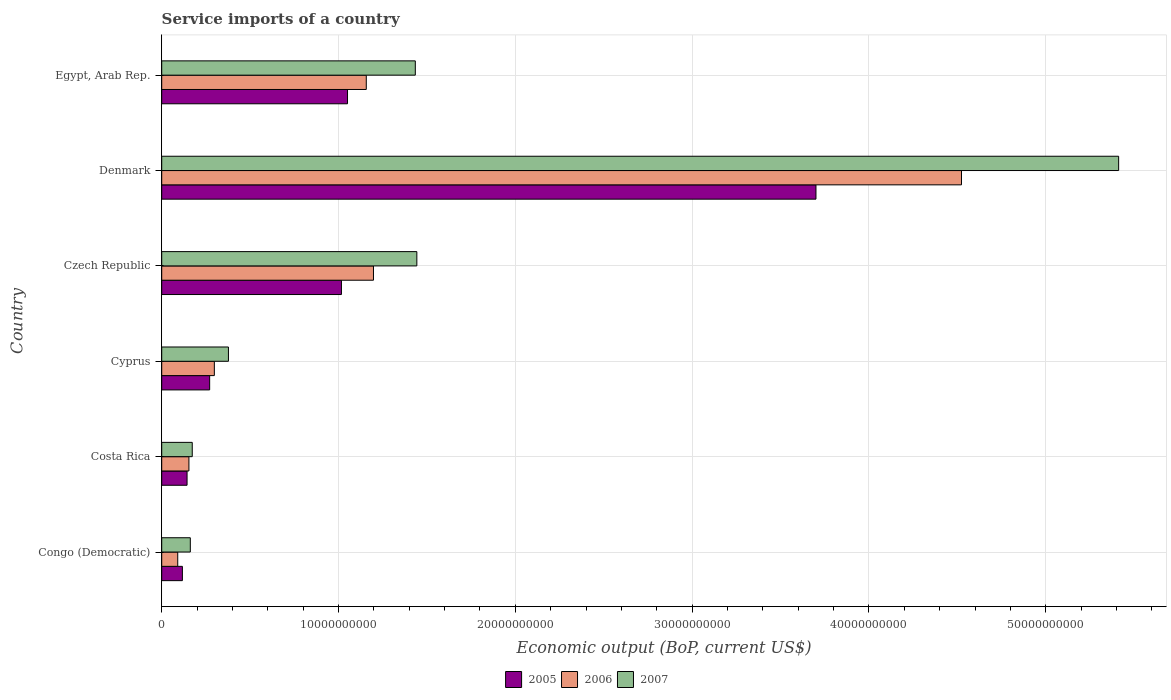How many different coloured bars are there?
Make the answer very short. 3. How many bars are there on the 5th tick from the top?
Your answer should be compact. 3. What is the label of the 3rd group of bars from the top?
Your answer should be compact. Czech Republic. In how many cases, is the number of bars for a given country not equal to the number of legend labels?
Your response must be concise. 0. What is the service imports in 2005 in Egypt, Arab Rep.?
Offer a very short reply. 1.05e+1. Across all countries, what is the maximum service imports in 2007?
Offer a terse response. 5.41e+1. Across all countries, what is the minimum service imports in 2007?
Make the answer very short. 1.62e+09. In which country was the service imports in 2007 maximum?
Make the answer very short. Denmark. In which country was the service imports in 2007 minimum?
Offer a very short reply. Congo (Democratic). What is the total service imports in 2006 in the graph?
Provide a succinct answer. 7.42e+1. What is the difference between the service imports in 2006 in Cyprus and that in Egypt, Arab Rep.?
Provide a short and direct response. -8.59e+09. What is the difference between the service imports in 2005 in Congo (Democratic) and the service imports in 2007 in Egypt, Arab Rep.?
Provide a short and direct response. -1.32e+1. What is the average service imports in 2006 per country?
Provide a succinct answer. 1.24e+1. What is the difference between the service imports in 2005 and service imports in 2007 in Denmark?
Ensure brevity in your answer.  -1.71e+1. What is the ratio of the service imports in 2006 in Congo (Democratic) to that in Cyprus?
Ensure brevity in your answer.  0.3. What is the difference between the highest and the second highest service imports in 2005?
Provide a short and direct response. 2.65e+1. What is the difference between the highest and the lowest service imports in 2007?
Offer a terse response. 5.25e+1. What does the 1st bar from the top in Czech Republic represents?
Offer a very short reply. 2007. Are the values on the major ticks of X-axis written in scientific E-notation?
Keep it short and to the point. No. Does the graph contain any zero values?
Make the answer very short. No. How many legend labels are there?
Keep it short and to the point. 3. What is the title of the graph?
Make the answer very short. Service imports of a country. What is the label or title of the X-axis?
Provide a short and direct response. Economic output (BoP, current US$). What is the Economic output (BoP, current US$) in 2005 in Congo (Democratic)?
Offer a terse response. 1.17e+09. What is the Economic output (BoP, current US$) of 2006 in Congo (Democratic)?
Make the answer very short. 9.06e+08. What is the Economic output (BoP, current US$) in 2007 in Congo (Democratic)?
Your response must be concise. 1.62e+09. What is the Economic output (BoP, current US$) of 2005 in Costa Rica?
Your answer should be very brief. 1.43e+09. What is the Economic output (BoP, current US$) of 2006 in Costa Rica?
Your answer should be compact. 1.54e+09. What is the Economic output (BoP, current US$) in 2007 in Costa Rica?
Make the answer very short. 1.73e+09. What is the Economic output (BoP, current US$) of 2005 in Cyprus?
Provide a succinct answer. 2.71e+09. What is the Economic output (BoP, current US$) of 2006 in Cyprus?
Provide a succinct answer. 2.98e+09. What is the Economic output (BoP, current US$) of 2007 in Cyprus?
Give a very brief answer. 3.77e+09. What is the Economic output (BoP, current US$) of 2005 in Czech Republic?
Your answer should be very brief. 1.02e+1. What is the Economic output (BoP, current US$) of 2006 in Czech Republic?
Make the answer very short. 1.20e+1. What is the Economic output (BoP, current US$) of 2007 in Czech Republic?
Offer a very short reply. 1.44e+1. What is the Economic output (BoP, current US$) in 2005 in Denmark?
Provide a short and direct response. 3.70e+1. What is the Economic output (BoP, current US$) in 2006 in Denmark?
Offer a very short reply. 4.52e+1. What is the Economic output (BoP, current US$) in 2007 in Denmark?
Provide a succinct answer. 5.41e+1. What is the Economic output (BoP, current US$) in 2005 in Egypt, Arab Rep.?
Keep it short and to the point. 1.05e+1. What is the Economic output (BoP, current US$) of 2006 in Egypt, Arab Rep.?
Provide a succinct answer. 1.16e+1. What is the Economic output (BoP, current US$) of 2007 in Egypt, Arab Rep.?
Provide a short and direct response. 1.43e+1. Across all countries, what is the maximum Economic output (BoP, current US$) of 2005?
Provide a short and direct response. 3.70e+1. Across all countries, what is the maximum Economic output (BoP, current US$) in 2006?
Offer a very short reply. 4.52e+1. Across all countries, what is the maximum Economic output (BoP, current US$) in 2007?
Keep it short and to the point. 5.41e+1. Across all countries, what is the minimum Economic output (BoP, current US$) in 2005?
Offer a very short reply. 1.17e+09. Across all countries, what is the minimum Economic output (BoP, current US$) of 2006?
Your answer should be compact. 9.06e+08. Across all countries, what is the minimum Economic output (BoP, current US$) of 2007?
Your response must be concise. 1.62e+09. What is the total Economic output (BoP, current US$) in 2005 in the graph?
Keep it short and to the point. 6.30e+1. What is the total Economic output (BoP, current US$) in 2006 in the graph?
Give a very brief answer. 7.42e+1. What is the total Economic output (BoP, current US$) in 2007 in the graph?
Make the answer very short. 9.00e+1. What is the difference between the Economic output (BoP, current US$) of 2005 in Congo (Democratic) and that in Costa Rica?
Keep it short and to the point. -2.65e+08. What is the difference between the Economic output (BoP, current US$) of 2006 in Congo (Democratic) and that in Costa Rica?
Provide a short and direct response. -6.33e+08. What is the difference between the Economic output (BoP, current US$) in 2007 in Congo (Democratic) and that in Costa Rica?
Provide a short and direct response. -1.09e+08. What is the difference between the Economic output (BoP, current US$) in 2005 in Congo (Democratic) and that in Cyprus?
Make the answer very short. -1.54e+09. What is the difference between the Economic output (BoP, current US$) in 2006 in Congo (Democratic) and that in Cyprus?
Ensure brevity in your answer.  -2.07e+09. What is the difference between the Economic output (BoP, current US$) of 2007 in Congo (Democratic) and that in Cyprus?
Your response must be concise. -2.16e+09. What is the difference between the Economic output (BoP, current US$) of 2005 in Congo (Democratic) and that in Czech Republic?
Offer a terse response. -9.00e+09. What is the difference between the Economic output (BoP, current US$) in 2006 in Congo (Democratic) and that in Czech Republic?
Ensure brevity in your answer.  -1.11e+1. What is the difference between the Economic output (BoP, current US$) in 2007 in Congo (Democratic) and that in Czech Republic?
Your answer should be compact. -1.28e+1. What is the difference between the Economic output (BoP, current US$) in 2005 in Congo (Democratic) and that in Denmark?
Your response must be concise. -3.58e+1. What is the difference between the Economic output (BoP, current US$) of 2006 in Congo (Democratic) and that in Denmark?
Offer a very short reply. -4.43e+1. What is the difference between the Economic output (BoP, current US$) of 2007 in Congo (Democratic) and that in Denmark?
Ensure brevity in your answer.  -5.25e+1. What is the difference between the Economic output (BoP, current US$) of 2005 in Congo (Democratic) and that in Egypt, Arab Rep.?
Offer a terse response. -9.34e+09. What is the difference between the Economic output (BoP, current US$) of 2006 in Congo (Democratic) and that in Egypt, Arab Rep.?
Make the answer very short. -1.07e+1. What is the difference between the Economic output (BoP, current US$) of 2007 in Congo (Democratic) and that in Egypt, Arab Rep.?
Your answer should be very brief. -1.27e+1. What is the difference between the Economic output (BoP, current US$) in 2005 in Costa Rica and that in Cyprus?
Keep it short and to the point. -1.28e+09. What is the difference between the Economic output (BoP, current US$) in 2006 in Costa Rica and that in Cyprus?
Offer a very short reply. -1.44e+09. What is the difference between the Economic output (BoP, current US$) of 2007 in Costa Rica and that in Cyprus?
Keep it short and to the point. -2.05e+09. What is the difference between the Economic output (BoP, current US$) of 2005 in Costa Rica and that in Czech Republic?
Make the answer very short. -8.73e+09. What is the difference between the Economic output (BoP, current US$) in 2006 in Costa Rica and that in Czech Republic?
Your answer should be compact. -1.04e+1. What is the difference between the Economic output (BoP, current US$) in 2007 in Costa Rica and that in Czech Republic?
Your response must be concise. -1.27e+1. What is the difference between the Economic output (BoP, current US$) of 2005 in Costa Rica and that in Denmark?
Your response must be concise. -3.56e+1. What is the difference between the Economic output (BoP, current US$) of 2006 in Costa Rica and that in Denmark?
Give a very brief answer. -4.37e+1. What is the difference between the Economic output (BoP, current US$) of 2007 in Costa Rica and that in Denmark?
Make the answer very short. -5.24e+1. What is the difference between the Economic output (BoP, current US$) of 2005 in Costa Rica and that in Egypt, Arab Rep.?
Ensure brevity in your answer.  -9.07e+09. What is the difference between the Economic output (BoP, current US$) in 2006 in Costa Rica and that in Egypt, Arab Rep.?
Provide a short and direct response. -1.00e+1. What is the difference between the Economic output (BoP, current US$) of 2007 in Costa Rica and that in Egypt, Arab Rep.?
Make the answer very short. -1.26e+1. What is the difference between the Economic output (BoP, current US$) in 2005 in Cyprus and that in Czech Republic?
Provide a succinct answer. -7.45e+09. What is the difference between the Economic output (BoP, current US$) in 2006 in Cyprus and that in Czech Republic?
Provide a short and direct response. -9.00e+09. What is the difference between the Economic output (BoP, current US$) in 2007 in Cyprus and that in Czech Republic?
Your answer should be very brief. -1.07e+1. What is the difference between the Economic output (BoP, current US$) in 2005 in Cyprus and that in Denmark?
Give a very brief answer. -3.43e+1. What is the difference between the Economic output (BoP, current US$) in 2006 in Cyprus and that in Denmark?
Provide a succinct answer. -4.23e+1. What is the difference between the Economic output (BoP, current US$) of 2007 in Cyprus and that in Denmark?
Ensure brevity in your answer.  -5.03e+1. What is the difference between the Economic output (BoP, current US$) of 2005 in Cyprus and that in Egypt, Arab Rep.?
Make the answer very short. -7.80e+09. What is the difference between the Economic output (BoP, current US$) in 2006 in Cyprus and that in Egypt, Arab Rep.?
Make the answer very short. -8.59e+09. What is the difference between the Economic output (BoP, current US$) of 2007 in Cyprus and that in Egypt, Arab Rep.?
Your response must be concise. -1.06e+1. What is the difference between the Economic output (BoP, current US$) of 2005 in Czech Republic and that in Denmark?
Offer a terse response. -2.68e+1. What is the difference between the Economic output (BoP, current US$) in 2006 in Czech Republic and that in Denmark?
Your answer should be very brief. -3.33e+1. What is the difference between the Economic output (BoP, current US$) in 2007 in Czech Republic and that in Denmark?
Provide a short and direct response. -3.97e+1. What is the difference between the Economic output (BoP, current US$) in 2005 in Czech Republic and that in Egypt, Arab Rep.?
Your answer should be compact. -3.44e+08. What is the difference between the Economic output (BoP, current US$) in 2006 in Czech Republic and that in Egypt, Arab Rep.?
Offer a terse response. 4.07e+08. What is the difference between the Economic output (BoP, current US$) in 2007 in Czech Republic and that in Egypt, Arab Rep.?
Offer a very short reply. 8.66e+07. What is the difference between the Economic output (BoP, current US$) in 2005 in Denmark and that in Egypt, Arab Rep.?
Offer a very short reply. 2.65e+1. What is the difference between the Economic output (BoP, current US$) in 2006 in Denmark and that in Egypt, Arab Rep.?
Give a very brief answer. 3.37e+1. What is the difference between the Economic output (BoP, current US$) in 2007 in Denmark and that in Egypt, Arab Rep.?
Make the answer very short. 3.98e+1. What is the difference between the Economic output (BoP, current US$) in 2005 in Congo (Democratic) and the Economic output (BoP, current US$) in 2006 in Costa Rica?
Keep it short and to the point. -3.70e+08. What is the difference between the Economic output (BoP, current US$) in 2005 in Congo (Democratic) and the Economic output (BoP, current US$) in 2007 in Costa Rica?
Give a very brief answer. -5.58e+08. What is the difference between the Economic output (BoP, current US$) in 2006 in Congo (Democratic) and the Economic output (BoP, current US$) in 2007 in Costa Rica?
Keep it short and to the point. -8.21e+08. What is the difference between the Economic output (BoP, current US$) in 2005 in Congo (Democratic) and the Economic output (BoP, current US$) in 2006 in Cyprus?
Provide a succinct answer. -1.81e+09. What is the difference between the Economic output (BoP, current US$) of 2005 in Congo (Democratic) and the Economic output (BoP, current US$) of 2007 in Cyprus?
Keep it short and to the point. -2.60e+09. What is the difference between the Economic output (BoP, current US$) of 2006 in Congo (Democratic) and the Economic output (BoP, current US$) of 2007 in Cyprus?
Your answer should be very brief. -2.87e+09. What is the difference between the Economic output (BoP, current US$) of 2005 in Congo (Democratic) and the Economic output (BoP, current US$) of 2006 in Czech Republic?
Keep it short and to the point. -1.08e+1. What is the difference between the Economic output (BoP, current US$) of 2005 in Congo (Democratic) and the Economic output (BoP, current US$) of 2007 in Czech Republic?
Provide a short and direct response. -1.33e+1. What is the difference between the Economic output (BoP, current US$) of 2006 in Congo (Democratic) and the Economic output (BoP, current US$) of 2007 in Czech Republic?
Provide a short and direct response. -1.35e+1. What is the difference between the Economic output (BoP, current US$) of 2005 in Congo (Democratic) and the Economic output (BoP, current US$) of 2006 in Denmark?
Your response must be concise. -4.41e+1. What is the difference between the Economic output (BoP, current US$) in 2005 in Congo (Democratic) and the Economic output (BoP, current US$) in 2007 in Denmark?
Ensure brevity in your answer.  -5.30e+1. What is the difference between the Economic output (BoP, current US$) of 2006 in Congo (Democratic) and the Economic output (BoP, current US$) of 2007 in Denmark?
Your answer should be compact. -5.32e+1. What is the difference between the Economic output (BoP, current US$) in 2005 in Congo (Democratic) and the Economic output (BoP, current US$) in 2006 in Egypt, Arab Rep.?
Provide a short and direct response. -1.04e+1. What is the difference between the Economic output (BoP, current US$) in 2005 in Congo (Democratic) and the Economic output (BoP, current US$) in 2007 in Egypt, Arab Rep.?
Give a very brief answer. -1.32e+1. What is the difference between the Economic output (BoP, current US$) of 2006 in Congo (Democratic) and the Economic output (BoP, current US$) of 2007 in Egypt, Arab Rep.?
Offer a terse response. -1.34e+1. What is the difference between the Economic output (BoP, current US$) of 2005 in Costa Rica and the Economic output (BoP, current US$) of 2006 in Cyprus?
Provide a succinct answer. -1.54e+09. What is the difference between the Economic output (BoP, current US$) in 2005 in Costa Rica and the Economic output (BoP, current US$) in 2007 in Cyprus?
Give a very brief answer. -2.34e+09. What is the difference between the Economic output (BoP, current US$) in 2006 in Costa Rica and the Economic output (BoP, current US$) in 2007 in Cyprus?
Offer a very short reply. -2.23e+09. What is the difference between the Economic output (BoP, current US$) in 2005 in Costa Rica and the Economic output (BoP, current US$) in 2006 in Czech Republic?
Your response must be concise. -1.05e+1. What is the difference between the Economic output (BoP, current US$) of 2005 in Costa Rica and the Economic output (BoP, current US$) of 2007 in Czech Republic?
Your answer should be compact. -1.30e+1. What is the difference between the Economic output (BoP, current US$) of 2006 in Costa Rica and the Economic output (BoP, current US$) of 2007 in Czech Republic?
Provide a short and direct response. -1.29e+1. What is the difference between the Economic output (BoP, current US$) in 2005 in Costa Rica and the Economic output (BoP, current US$) in 2006 in Denmark?
Offer a very short reply. -4.38e+1. What is the difference between the Economic output (BoP, current US$) in 2005 in Costa Rica and the Economic output (BoP, current US$) in 2007 in Denmark?
Provide a short and direct response. -5.27e+1. What is the difference between the Economic output (BoP, current US$) of 2006 in Costa Rica and the Economic output (BoP, current US$) of 2007 in Denmark?
Provide a short and direct response. -5.26e+1. What is the difference between the Economic output (BoP, current US$) in 2005 in Costa Rica and the Economic output (BoP, current US$) in 2006 in Egypt, Arab Rep.?
Your response must be concise. -1.01e+1. What is the difference between the Economic output (BoP, current US$) of 2005 in Costa Rica and the Economic output (BoP, current US$) of 2007 in Egypt, Arab Rep.?
Provide a short and direct response. -1.29e+1. What is the difference between the Economic output (BoP, current US$) in 2006 in Costa Rica and the Economic output (BoP, current US$) in 2007 in Egypt, Arab Rep.?
Your response must be concise. -1.28e+1. What is the difference between the Economic output (BoP, current US$) of 2005 in Cyprus and the Economic output (BoP, current US$) of 2006 in Czech Republic?
Make the answer very short. -9.26e+09. What is the difference between the Economic output (BoP, current US$) in 2005 in Cyprus and the Economic output (BoP, current US$) in 2007 in Czech Republic?
Your answer should be very brief. -1.17e+1. What is the difference between the Economic output (BoP, current US$) of 2006 in Cyprus and the Economic output (BoP, current US$) of 2007 in Czech Republic?
Your answer should be compact. -1.15e+1. What is the difference between the Economic output (BoP, current US$) in 2005 in Cyprus and the Economic output (BoP, current US$) in 2006 in Denmark?
Your answer should be compact. -4.25e+1. What is the difference between the Economic output (BoP, current US$) of 2005 in Cyprus and the Economic output (BoP, current US$) of 2007 in Denmark?
Keep it short and to the point. -5.14e+1. What is the difference between the Economic output (BoP, current US$) of 2006 in Cyprus and the Economic output (BoP, current US$) of 2007 in Denmark?
Make the answer very short. -5.11e+1. What is the difference between the Economic output (BoP, current US$) in 2005 in Cyprus and the Economic output (BoP, current US$) in 2006 in Egypt, Arab Rep.?
Give a very brief answer. -8.86e+09. What is the difference between the Economic output (BoP, current US$) in 2005 in Cyprus and the Economic output (BoP, current US$) in 2007 in Egypt, Arab Rep.?
Offer a terse response. -1.16e+1. What is the difference between the Economic output (BoP, current US$) in 2006 in Cyprus and the Economic output (BoP, current US$) in 2007 in Egypt, Arab Rep.?
Your answer should be compact. -1.14e+1. What is the difference between the Economic output (BoP, current US$) in 2005 in Czech Republic and the Economic output (BoP, current US$) in 2006 in Denmark?
Provide a succinct answer. -3.51e+1. What is the difference between the Economic output (BoP, current US$) of 2005 in Czech Republic and the Economic output (BoP, current US$) of 2007 in Denmark?
Provide a short and direct response. -4.40e+1. What is the difference between the Economic output (BoP, current US$) of 2006 in Czech Republic and the Economic output (BoP, current US$) of 2007 in Denmark?
Your answer should be compact. -4.21e+1. What is the difference between the Economic output (BoP, current US$) in 2005 in Czech Republic and the Economic output (BoP, current US$) in 2006 in Egypt, Arab Rep.?
Offer a very short reply. -1.40e+09. What is the difference between the Economic output (BoP, current US$) of 2005 in Czech Republic and the Economic output (BoP, current US$) of 2007 in Egypt, Arab Rep.?
Offer a very short reply. -4.18e+09. What is the difference between the Economic output (BoP, current US$) of 2006 in Czech Republic and the Economic output (BoP, current US$) of 2007 in Egypt, Arab Rep.?
Provide a succinct answer. -2.37e+09. What is the difference between the Economic output (BoP, current US$) in 2005 in Denmark and the Economic output (BoP, current US$) in 2006 in Egypt, Arab Rep.?
Provide a succinct answer. 2.54e+1. What is the difference between the Economic output (BoP, current US$) in 2005 in Denmark and the Economic output (BoP, current US$) in 2007 in Egypt, Arab Rep.?
Your answer should be very brief. 2.27e+1. What is the difference between the Economic output (BoP, current US$) of 2006 in Denmark and the Economic output (BoP, current US$) of 2007 in Egypt, Arab Rep.?
Offer a very short reply. 3.09e+1. What is the average Economic output (BoP, current US$) in 2005 per country?
Your answer should be compact. 1.05e+1. What is the average Economic output (BoP, current US$) in 2006 per country?
Provide a succinct answer. 1.24e+1. What is the average Economic output (BoP, current US$) of 2007 per country?
Your response must be concise. 1.50e+1. What is the difference between the Economic output (BoP, current US$) in 2005 and Economic output (BoP, current US$) in 2006 in Congo (Democratic)?
Provide a short and direct response. 2.63e+08. What is the difference between the Economic output (BoP, current US$) in 2005 and Economic output (BoP, current US$) in 2007 in Congo (Democratic)?
Your response must be concise. -4.48e+08. What is the difference between the Economic output (BoP, current US$) in 2006 and Economic output (BoP, current US$) in 2007 in Congo (Democratic)?
Your answer should be compact. -7.12e+08. What is the difference between the Economic output (BoP, current US$) in 2005 and Economic output (BoP, current US$) in 2006 in Costa Rica?
Offer a very short reply. -1.05e+08. What is the difference between the Economic output (BoP, current US$) in 2005 and Economic output (BoP, current US$) in 2007 in Costa Rica?
Give a very brief answer. -2.93e+08. What is the difference between the Economic output (BoP, current US$) in 2006 and Economic output (BoP, current US$) in 2007 in Costa Rica?
Offer a terse response. -1.88e+08. What is the difference between the Economic output (BoP, current US$) of 2005 and Economic output (BoP, current US$) of 2006 in Cyprus?
Provide a short and direct response. -2.65e+08. What is the difference between the Economic output (BoP, current US$) in 2005 and Economic output (BoP, current US$) in 2007 in Cyprus?
Keep it short and to the point. -1.06e+09. What is the difference between the Economic output (BoP, current US$) in 2006 and Economic output (BoP, current US$) in 2007 in Cyprus?
Your answer should be compact. -7.96e+08. What is the difference between the Economic output (BoP, current US$) in 2005 and Economic output (BoP, current US$) in 2006 in Czech Republic?
Your answer should be compact. -1.81e+09. What is the difference between the Economic output (BoP, current US$) in 2005 and Economic output (BoP, current US$) in 2007 in Czech Republic?
Keep it short and to the point. -4.26e+09. What is the difference between the Economic output (BoP, current US$) of 2006 and Economic output (BoP, current US$) of 2007 in Czech Republic?
Your answer should be very brief. -2.45e+09. What is the difference between the Economic output (BoP, current US$) of 2005 and Economic output (BoP, current US$) of 2006 in Denmark?
Give a very brief answer. -8.23e+09. What is the difference between the Economic output (BoP, current US$) of 2005 and Economic output (BoP, current US$) of 2007 in Denmark?
Provide a succinct answer. -1.71e+1. What is the difference between the Economic output (BoP, current US$) in 2006 and Economic output (BoP, current US$) in 2007 in Denmark?
Your answer should be compact. -8.89e+09. What is the difference between the Economic output (BoP, current US$) in 2005 and Economic output (BoP, current US$) in 2006 in Egypt, Arab Rep.?
Provide a succinct answer. -1.06e+09. What is the difference between the Economic output (BoP, current US$) of 2005 and Economic output (BoP, current US$) of 2007 in Egypt, Arab Rep.?
Your answer should be compact. -3.83e+09. What is the difference between the Economic output (BoP, current US$) in 2006 and Economic output (BoP, current US$) in 2007 in Egypt, Arab Rep.?
Your answer should be very brief. -2.77e+09. What is the ratio of the Economic output (BoP, current US$) in 2005 in Congo (Democratic) to that in Costa Rica?
Offer a very short reply. 0.82. What is the ratio of the Economic output (BoP, current US$) of 2006 in Congo (Democratic) to that in Costa Rica?
Provide a short and direct response. 0.59. What is the ratio of the Economic output (BoP, current US$) in 2007 in Congo (Democratic) to that in Costa Rica?
Give a very brief answer. 0.94. What is the ratio of the Economic output (BoP, current US$) in 2005 in Congo (Democratic) to that in Cyprus?
Offer a terse response. 0.43. What is the ratio of the Economic output (BoP, current US$) in 2006 in Congo (Democratic) to that in Cyprus?
Your answer should be compact. 0.3. What is the ratio of the Economic output (BoP, current US$) of 2007 in Congo (Democratic) to that in Cyprus?
Give a very brief answer. 0.43. What is the ratio of the Economic output (BoP, current US$) of 2005 in Congo (Democratic) to that in Czech Republic?
Your answer should be very brief. 0.12. What is the ratio of the Economic output (BoP, current US$) of 2006 in Congo (Democratic) to that in Czech Republic?
Ensure brevity in your answer.  0.08. What is the ratio of the Economic output (BoP, current US$) of 2007 in Congo (Democratic) to that in Czech Republic?
Your response must be concise. 0.11. What is the ratio of the Economic output (BoP, current US$) in 2005 in Congo (Democratic) to that in Denmark?
Your answer should be very brief. 0.03. What is the ratio of the Economic output (BoP, current US$) of 2006 in Congo (Democratic) to that in Denmark?
Offer a terse response. 0.02. What is the ratio of the Economic output (BoP, current US$) of 2007 in Congo (Democratic) to that in Denmark?
Your response must be concise. 0.03. What is the ratio of the Economic output (BoP, current US$) in 2005 in Congo (Democratic) to that in Egypt, Arab Rep.?
Offer a very short reply. 0.11. What is the ratio of the Economic output (BoP, current US$) in 2006 in Congo (Democratic) to that in Egypt, Arab Rep.?
Keep it short and to the point. 0.08. What is the ratio of the Economic output (BoP, current US$) of 2007 in Congo (Democratic) to that in Egypt, Arab Rep.?
Offer a terse response. 0.11. What is the ratio of the Economic output (BoP, current US$) of 2005 in Costa Rica to that in Cyprus?
Ensure brevity in your answer.  0.53. What is the ratio of the Economic output (BoP, current US$) in 2006 in Costa Rica to that in Cyprus?
Your answer should be very brief. 0.52. What is the ratio of the Economic output (BoP, current US$) of 2007 in Costa Rica to that in Cyprus?
Provide a short and direct response. 0.46. What is the ratio of the Economic output (BoP, current US$) in 2005 in Costa Rica to that in Czech Republic?
Ensure brevity in your answer.  0.14. What is the ratio of the Economic output (BoP, current US$) of 2006 in Costa Rica to that in Czech Republic?
Provide a succinct answer. 0.13. What is the ratio of the Economic output (BoP, current US$) of 2007 in Costa Rica to that in Czech Republic?
Give a very brief answer. 0.12. What is the ratio of the Economic output (BoP, current US$) of 2005 in Costa Rica to that in Denmark?
Provide a short and direct response. 0.04. What is the ratio of the Economic output (BoP, current US$) in 2006 in Costa Rica to that in Denmark?
Provide a short and direct response. 0.03. What is the ratio of the Economic output (BoP, current US$) in 2007 in Costa Rica to that in Denmark?
Your answer should be very brief. 0.03. What is the ratio of the Economic output (BoP, current US$) of 2005 in Costa Rica to that in Egypt, Arab Rep.?
Your answer should be very brief. 0.14. What is the ratio of the Economic output (BoP, current US$) of 2006 in Costa Rica to that in Egypt, Arab Rep.?
Make the answer very short. 0.13. What is the ratio of the Economic output (BoP, current US$) of 2007 in Costa Rica to that in Egypt, Arab Rep.?
Your answer should be compact. 0.12. What is the ratio of the Economic output (BoP, current US$) of 2005 in Cyprus to that in Czech Republic?
Your answer should be very brief. 0.27. What is the ratio of the Economic output (BoP, current US$) of 2006 in Cyprus to that in Czech Republic?
Provide a succinct answer. 0.25. What is the ratio of the Economic output (BoP, current US$) of 2007 in Cyprus to that in Czech Republic?
Keep it short and to the point. 0.26. What is the ratio of the Economic output (BoP, current US$) in 2005 in Cyprus to that in Denmark?
Provide a succinct answer. 0.07. What is the ratio of the Economic output (BoP, current US$) of 2006 in Cyprus to that in Denmark?
Give a very brief answer. 0.07. What is the ratio of the Economic output (BoP, current US$) in 2007 in Cyprus to that in Denmark?
Provide a succinct answer. 0.07. What is the ratio of the Economic output (BoP, current US$) in 2005 in Cyprus to that in Egypt, Arab Rep.?
Make the answer very short. 0.26. What is the ratio of the Economic output (BoP, current US$) in 2006 in Cyprus to that in Egypt, Arab Rep.?
Your response must be concise. 0.26. What is the ratio of the Economic output (BoP, current US$) of 2007 in Cyprus to that in Egypt, Arab Rep.?
Give a very brief answer. 0.26. What is the ratio of the Economic output (BoP, current US$) in 2005 in Czech Republic to that in Denmark?
Your answer should be very brief. 0.27. What is the ratio of the Economic output (BoP, current US$) of 2006 in Czech Republic to that in Denmark?
Keep it short and to the point. 0.26. What is the ratio of the Economic output (BoP, current US$) of 2007 in Czech Republic to that in Denmark?
Ensure brevity in your answer.  0.27. What is the ratio of the Economic output (BoP, current US$) in 2005 in Czech Republic to that in Egypt, Arab Rep.?
Make the answer very short. 0.97. What is the ratio of the Economic output (BoP, current US$) in 2006 in Czech Republic to that in Egypt, Arab Rep.?
Provide a short and direct response. 1.04. What is the ratio of the Economic output (BoP, current US$) in 2007 in Czech Republic to that in Egypt, Arab Rep.?
Ensure brevity in your answer.  1.01. What is the ratio of the Economic output (BoP, current US$) of 2005 in Denmark to that in Egypt, Arab Rep.?
Make the answer very short. 3.52. What is the ratio of the Economic output (BoP, current US$) in 2006 in Denmark to that in Egypt, Arab Rep.?
Your answer should be very brief. 3.91. What is the ratio of the Economic output (BoP, current US$) of 2007 in Denmark to that in Egypt, Arab Rep.?
Your answer should be very brief. 3.77. What is the difference between the highest and the second highest Economic output (BoP, current US$) of 2005?
Ensure brevity in your answer.  2.65e+1. What is the difference between the highest and the second highest Economic output (BoP, current US$) of 2006?
Make the answer very short. 3.33e+1. What is the difference between the highest and the second highest Economic output (BoP, current US$) in 2007?
Make the answer very short. 3.97e+1. What is the difference between the highest and the lowest Economic output (BoP, current US$) of 2005?
Keep it short and to the point. 3.58e+1. What is the difference between the highest and the lowest Economic output (BoP, current US$) in 2006?
Your response must be concise. 4.43e+1. What is the difference between the highest and the lowest Economic output (BoP, current US$) in 2007?
Provide a short and direct response. 5.25e+1. 